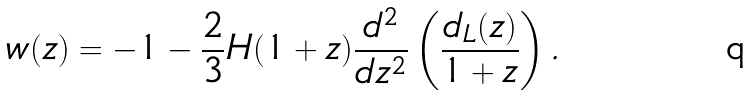Convert formula to latex. <formula><loc_0><loc_0><loc_500><loc_500>w ( z ) = - 1 - \frac { 2 } { 3 } H ( 1 + z ) \frac { d ^ { 2 } } { d z ^ { 2 } } \left ( \frac { d _ { L } ( z ) } { 1 + z } \right ) .</formula> 